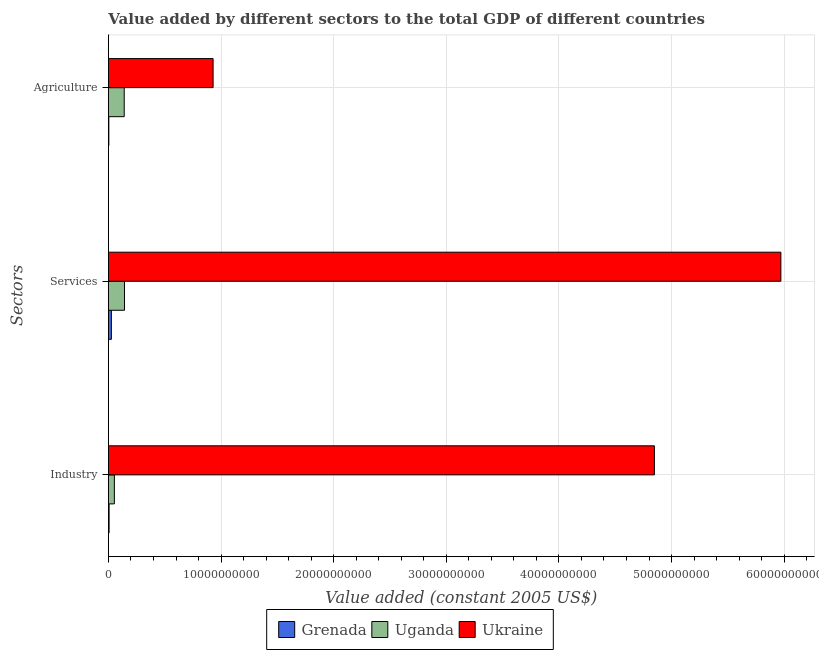How many groups of bars are there?
Provide a short and direct response. 3. What is the label of the 3rd group of bars from the top?
Provide a short and direct response. Industry. What is the value added by services in Grenada?
Provide a succinct answer. 2.62e+08. Across all countries, what is the maximum value added by services?
Ensure brevity in your answer.  5.97e+1. Across all countries, what is the minimum value added by industrial sector?
Ensure brevity in your answer.  5.87e+07. In which country was the value added by services maximum?
Ensure brevity in your answer.  Ukraine. In which country was the value added by industrial sector minimum?
Your response must be concise. Grenada. What is the total value added by agricultural sector in the graph?
Give a very brief answer. 1.07e+1. What is the difference between the value added by services in Uganda and that in Grenada?
Your answer should be very brief. 1.17e+09. What is the difference between the value added by agricultural sector in Uganda and the value added by services in Grenada?
Provide a succinct answer. 1.14e+09. What is the average value added by services per country?
Your answer should be very brief. 2.05e+1. What is the difference between the value added by agricultural sector and value added by services in Uganda?
Keep it short and to the point. -2.46e+07. In how many countries, is the value added by agricultural sector greater than 34000000000 US$?
Your answer should be compact. 0. What is the ratio of the value added by industrial sector in Uganda to that in Ukraine?
Provide a succinct answer. 0.01. Is the difference between the value added by industrial sector in Grenada and Uganda greater than the difference between the value added by agricultural sector in Grenada and Uganda?
Provide a succinct answer. Yes. What is the difference between the highest and the second highest value added by industrial sector?
Offer a terse response. 4.80e+1. What is the difference between the highest and the lowest value added by agricultural sector?
Ensure brevity in your answer.  9.26e+09. Is the sum of the value added by agricultural sector in Uganda and Grenada greater than the maximum value added by services across all countries?
Offer a terse response. No. What does the 2nd bar from the top in Services represents?
Give a very brief answer. Uganda. What does the 2nd bar from the bottom in Agriculture represents?
Your response must be concise. Uganda. Is it the case that in every country, the sum of the value added by industrial sector and value added by services is greater than the value added by agricultural sector?
Offer a terse response. Yes. How many countries are there in the graph?
Your answer should be compact. 3. Are the values on the major ticks of X-axis written in scientific E-notation?
Provide a short and direct response. No. Where does the legend appear in the graph?
Your response must be concise. Bottom center. How are the legend labels stacked?
Give a very brief answer. Horizontal. What is the title of the graph?
Give a very brief answer. Value added by different sectors to the total GDP of different countries. Does "Isle of Man" appear as one of the legend labels in the graph?
Give a very brief answer. No. What is the label or title of the X-axis?
Keep it short and to the point. Value added (constant 2005 US$). What is the label or title of the Y-axis?
Give a very brief answer. Sectors. What is the Value added (constant 2005 US$) of Grenada in Industry?
Provide a short and direct response. 5.87e+07. What is the Value added (constant 2005 US$) in Uganda in Industry?
Your answer should be compact. 5.28e+08. What is the Value added (constant 2005 US$) in Ukraine in Industry?
Give a very brief answer. 4.85e+1. What is the Value added (constant 2005 US$) of Grenada in Services?
Your response must be concise. 2.62e+08. What is the Value added (constant 2005 US$) in Uganda in Services?
Ensure brevity in your answer.  1.43e+09. What is the Value added (constant 2005 US$) of Ukraine in Services?
Keep it short and to the point. 5.97e+1. What is the Value added (constant 2005 US$) in Grenada in Agriculture?
Make the answer very short. 3.69e+07. What is the Value added (constant 2005 US$) in Uganda in Agriculture?
Provide a succinct answer. 1.40e+09. What is the Value added (constant 2005 US$) in Ukraine in Agriculture?
Your answer should be compact. 9.29e+09. Across all Sectors, what is the maximum Value added (constant 2005 US$) of Grenada?
Make the answer very short. 2.62e+08. Across all Sectors, what is the maximum Value added (constant 2005 US$) of Uganda?
Your answer should be very brief. 1.43e+09. Across all Sectors, what is the maximum Value added (constant 2005 US$) of Ukraine?
Ensure brevity in your answer.  5.97e+1. Across all Sectors, what is the minimum Value added (constant 2005 US$) in Grenada?
Make the answer very short. 3.69e+07. Across all Sectors, what is the minimum Value added (constant 2005 US$) in Uganda?
Provide a succinct answer. 5.28e+08. Across all Sectors, what is the minimum Value added (constant 2005 US$) in Ukraine?
Your answer should be compact. 9.29e+09. What is the total Value added (constant 2005 US$) of Grenada in the graph?
Your answer should be very brief. 3.57e+08. What is the total Value added (constant 2005 US$) of Uganda in the graph?
Offer a very short reply. 3.36e+09. What is the total Value added (constant 2005 US$) of Ukraine in the graph?
Offer a very short reply. 1.17e+11. What is the difference between the Value added (constant 2005 US$) in Grenada in Industry and that in Services?
Provide a short and direct response. -2.03e+08. What is the difference between the Value added (constant 2005 US$) of Uganda in Industry and that in Services?
Provide a short and direct response. -8.99e+08. What is the difference between the Value added (constant 2005 US$) of Ukraine in Industry and that in Services?
Your response must be concise. -1.12e+1. What is the difference between the Value added (constant 2005 US$) in Grenada in Industry and that in Agriculture?
Provide a succinct answer. 2.18e+07. What is the difference between the Value added (constant 2005 US$) in Uganda in Industry and that in Agriculture?
Your answer should be compact. -8.74e+08. What is the difference between the Value added (constant 2005 US$) of Ukraine in Industry and that in Agriculture?
Your answer should be very brief. 3.92e+1. What is the difference between the Value added (constant 2005 US$) in Grenada in Services and that in Agriculture?
Your answer should be compact. 2.25e+08. What is the difference between the Value added (constant 2005 US$) in Uganda in Services and that in Agriculture?
Ensure brevity in your answer.  2.46e+07. What is the difference between the Value added (constant 2005 US$) in Ukraine in Services and that in Agriculture?
Offer a terse response. 5.04e+1. What is the difference between the Value added (constant 2005 US$) in Grenada in Industry and the Value added (constant 2005 US$) in Uganda in Services?
Keep it short and to the point. -1.37e+09. What is the difference between the Value added (constant 2005 US$) of Grenada in Industry and the Value added (constant 2005 US$) of Ukraine in Services?
Your answer should be very brief. -5.96e+1. What is the difference between the Value added (constant 2005 US$) in Uganda in Industry and the Value added (constant 2005 US$) in Ukraine in Services?
Offer a terse response. -5.92e+1. What is the difference between the Value added (constant 2005 US$) in Grenada in Industry and the Value added (constant 2005 US$) in Uganda in Agriculture?
Offer a terse response. -1.34e+09. What is the difference between the Value added (constant 2005 US$) in Grenada in Industry and the Value added (constant 2005 US$) in Ukraine in Agriculture?
Provide a short and direct response. -9.24e+09. What is the difference between the Value added (constant 2005 US$) in Uganda in Industry and the Value added (constant 2005 US$) in Ukraine in Agriculture?
Your response must be concise. -8.77e+09. What is the difference between the Value added (constant 2005 US$) in Grenada in Services and the Value added (constant 2005 US$) in Uganda in Agriculture?
Make the answer very short. -1.14e+09. What is the difference between the Value added (constant 2005 US$) in Grenada in Services and the Value added (constant 2005 US$) in Ukraine in Agriculture?
Offer a terse response. -9.03e+09. What is the difference between the Value added (constant 2005 US$) of Uganda in Services and the Value added (constant 2005 US$) of Ukraine in Agriculture?
Offer a terse response. -7.87e+09. What is the average Value added (constant 2005 US$) in Grenada per Sectors?
Your response must be concise. 1.19e+08. What is the average Value added (constant 2005 US$) in Uganda per Sectors?
Provide a succinct answer. 1.12e+09. What is the average Value added (constant 2005 US$) in Ukraine per Sectors?
Your answer should be very brief. 3.92e+1. What is the difference between the Value added (constant 2005 US$) in Grenada and Value added (constant 2005 US$) in Uganda in Industry?
Offer a very short reply. -4.70e+08. What is the difference between the Value added (constant 2005 US$) in Grenada and Value added (constant 2005 US$) in Ukraine in Industry?
Your answer should be compact. -4.84e+1. What is the difference between the Value added (constant 2005 US$) in Uganda and Value added (constant 2005 US$) in Ukraine in Industry?
Provide a short and direct response. -4.80e+1. What is the difference between the Value added (constant 2005 US$) in Grenada and Value added (constant 2005 US$) in Uganda in Services?
Provide a short and direct response. -1.17e+09. What is the difference between the Value added (constant 2005 US$) of Grenada and Value added (constant 2005 US$) of Ukraine in Services?
Offer a terse response. -5.94e+1. What is the difference between the Value added (constant 2005 US$) of Uganda and Value added (constant 2005 US$) of Ukraine in Services?
Your answer should be very brief. -5.83e+1. What is the difference between the Value added (constant 2005 US$) in Grenada and Value added (constant 2005 US$) in Uganda in Agriculture?
Provide a succinct answer. -1.37e+09. What is the difference between the Value added (constant 2005 US$) of Grenada and Value added (constant 2005 US$) of Ukraine in Agriculture?
Offer a terse response. -9.26e+09. What is the difference between the Value added (constant 2005 US$) of Uganda and Value added (constant 2005 US$) of Ukraine in Agriculture?
Your answer should be very brief. -7.89e+09. What is the ratio of the Value added (constant 2005 US$) in Grenada in Industry to that in Services?
Your response must be concise. 0.22. What is the ratio of the Value added (constant 2005 US$) of Uganda in Industry to that in Services?
Your response must be concise. 0.37. What is the ratio of the Value added (constant 2005 US$) in Ukraine in Industry to that in Services?
Provide a short and direct response. 0.81. What is the ratio of the Value added (constant 2005 US$) of Grenada in Industry to that in Agriculture?
Make the answer very short. 1.59. What is the ratio of the Value added (constant 2005 US$) in Uganda in Industry to that in Agriculture?
Offer a terse response. 0.38. What is the ratio of the Value added (constant 2005 US$) in Ukraine in Industry to that in Agriculture?
Your answer should be compact. 5.22. What is the ratio of the Value added (constant 2005 US$) of Grenada in Services to that in Agriculture?
Make the answer very short. 7.09. What is the ratio of the Value added (constant 2005 US$) in Uganda in Services to that in Agriculture?
Keep it short and to the point. 1.02. What is the ratio of the Value added (constant 2005 US$) in Ukraine in Services to that in Agriculture?
Ensure brevity in your answer.  6.42. What is the difference between the highest and the second highest Value added (constant 2005 US$) in Grenada?
Ensure brevity in your answer.  2.03e+08. What is the difference between the highest and the second highest Value added (constant 2005 US$) of Uganda?
Offer a terse response. 2.46e+07. What is the difference between the highest and the second highest Value added (constant 2005 US$) in Ukraine?
Your answer should be compact. 1.12e+1. What is the difference between the highest and the lowest Value added (constant 2005 US$) of Grenada?
Provide a succinct answer. 2.25e+08. What is the difference between the highest and the lowest Value added (constant 2005 US$) of Uganda?
Provide a short and direct response. 8.99e+08. What is the difference between the highest and the lowest Value added (constant 2005 US$) of Ukraine?
Offer a terse response. 5.04e+1. 